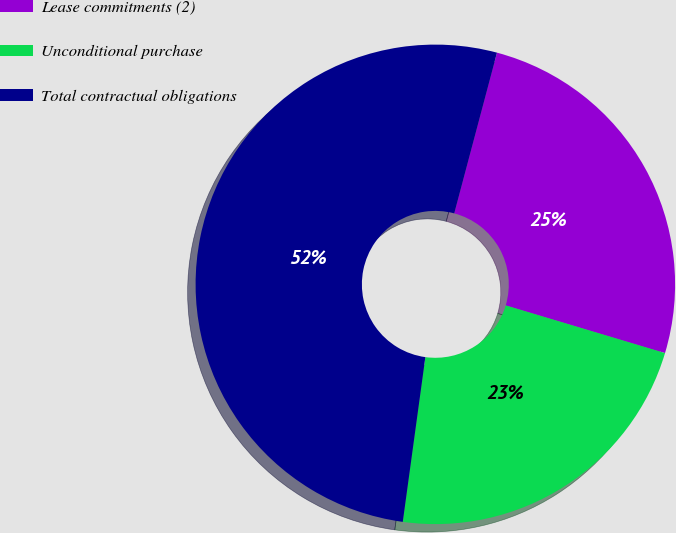<chart> <loc_0><loc_0><loc_500><loc_500><pie_chart><fcel>Lease commitments (2)<fcel>Unconditional purchase<fcel>Total contractual obligations<nl><fcel>25.49%<fcel>22.54%<fcel>51.97%<nl></chart> 